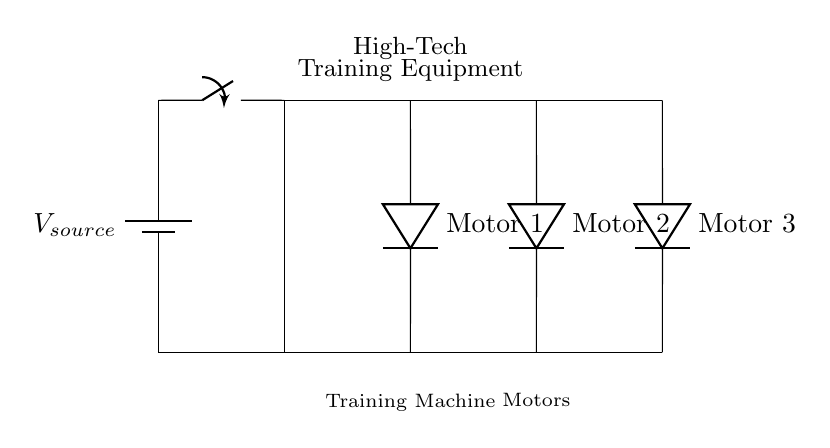What is the source voltage of the circuit? The source voltage is labeled as V source on the battery component. This indicates the potential difference provided by the battery to the circuit.
Answer: V source How many motors are connected in this circuit? The circuit shows three motor components labeled as Motor 1, Motor 2, and Motor 3. Each motor is connected in parallel across the same voltage source.
Answer: 3 What is the connection type of this circuit? The diagram indicates that the motors are arranged in parallel as they connect to the same voltage source and share the same two nodes for connection. This means that each motor operates independently of the others.
Answer: Parallel What is the role of the switch in this circuit? The switch allows or interrupts the flow of electricity from the voltage source to the connected motors. When the switch is closed, the circuit is complete, and current can flow to the motors.
Answer: Control flow If one motor fails, what happens to the others? In a parallel circuit, if one motor fails, the other motors remain functional as they have their own individual connections to the voltage source. This is a key feature of parallel circuits, allowing for reliability and continuity in operation.
Answer: Remain functional What would be the total current drawn from the source if all motors operate at the same current? In a parallel circuit, the total current is the sum of the currents through each motor. If each motor draws the same current, the total current would be three times the individual motor current. To calculate the specific value, you would need the individual motor current.
Answer: Sum of the currents 